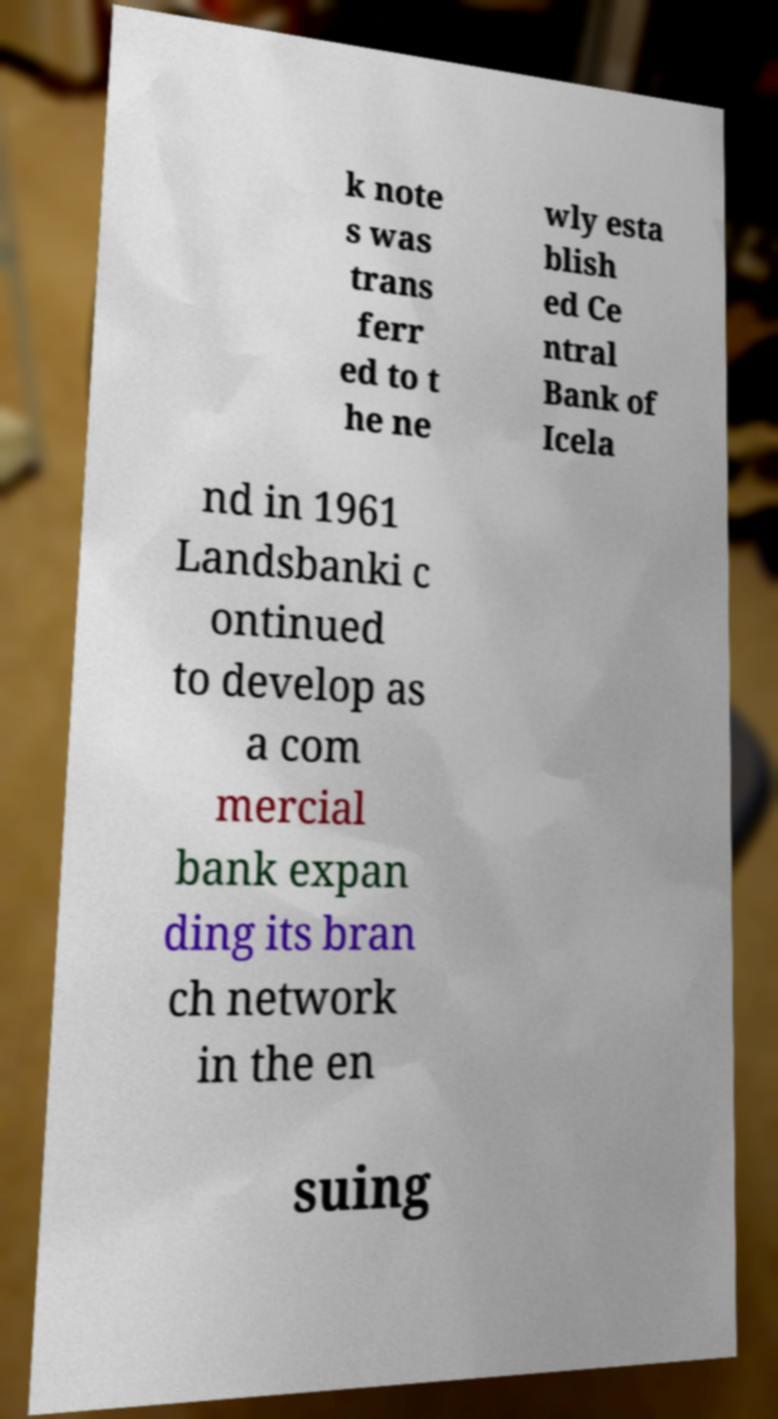Can you read and provide the text displayed in the image?This photo seems to have some interesting text. Can you extract and type it out for me? k note s was trans ferr ed to t he ne wly esta blish ed Ce ntral Bank of Icela nd in 1961 Landsbanki c ontinued to develop as a com mercial bank expan ding its bran ch network in the en suing 